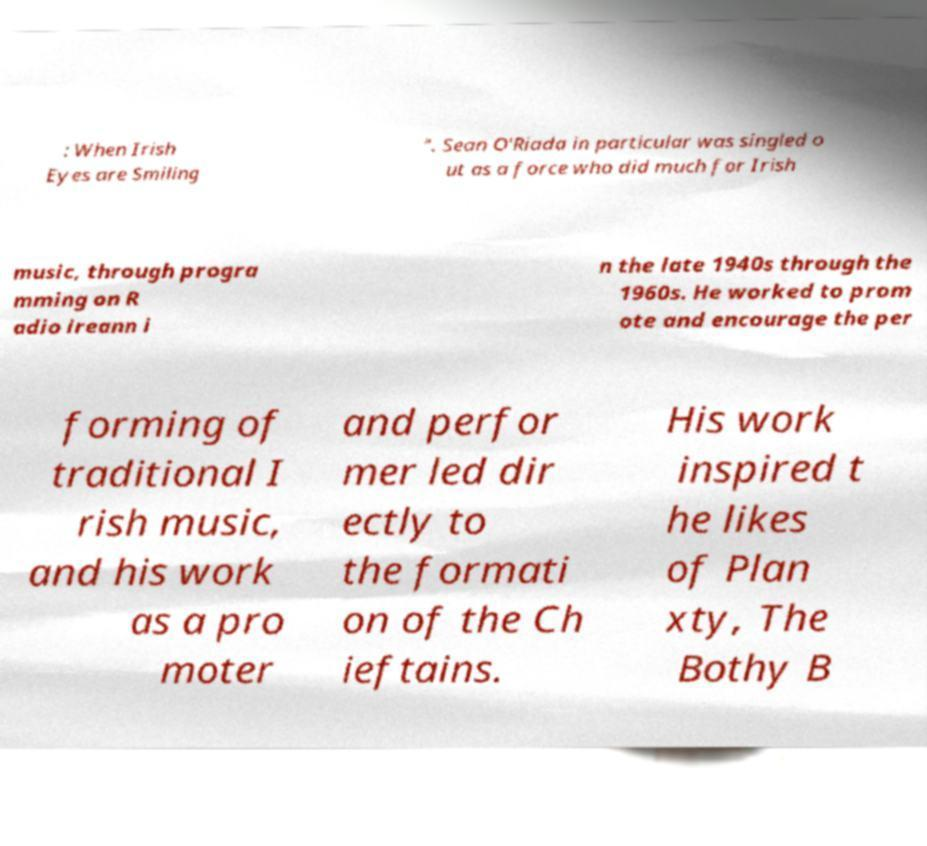For documentation purposes, I need the text within this image transcribed. Could you provide that? : When Irish Eyes are Smiling ". Sean O'Riada in particular was singled o ut as a force who did much for Irish music, through progra mming on R adio ireann i n the late 1940s through the 1960s. He worked to prom ote and encourage the per forming of traditional I rish music, and his work as a pro moter and perfor mer led dir ectly to the formati on of the Ch ieftains. His work inspired t he likes of Plan xty, The Bothy B 